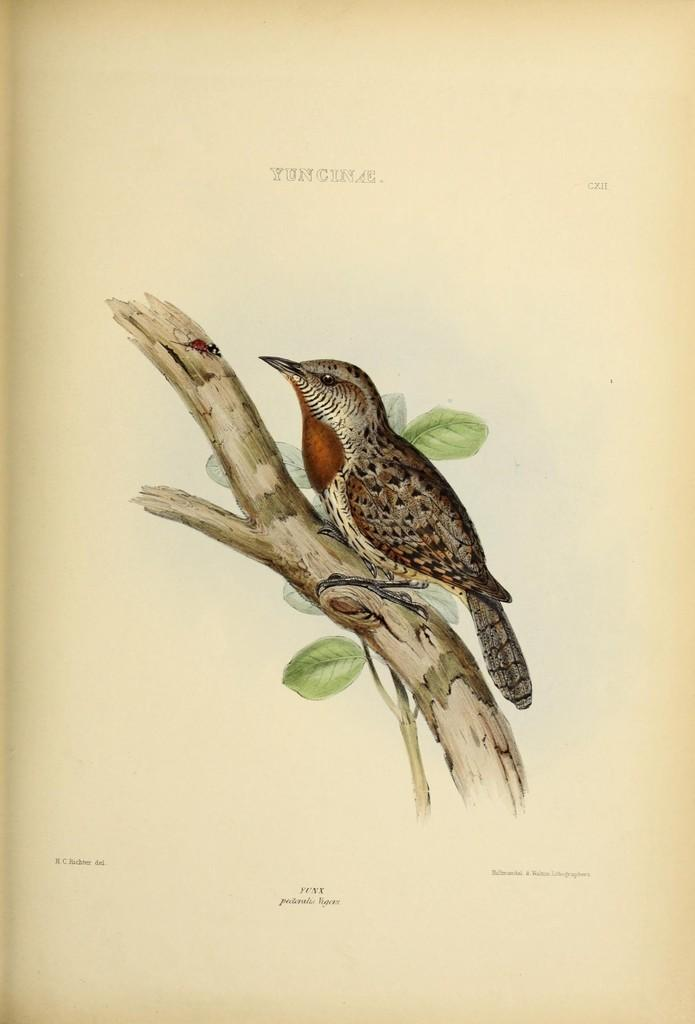What can be found on the page in the image? There is writing on the page and a painting of a bird. Can you describe the bird in the painting? The bird is sitting on a tree trunk in the painting. What other elements are present in the painting? There are leaves and a stem depicted in the painting. How many books are visible in the image? There are no books visible in the image; it only features a page with writing and a painting of a bird. What type of clouds can be seen in the painting? There are no clouds depicted in the painting; it only features a bird, a tree trunk, leaves, and a stem. 